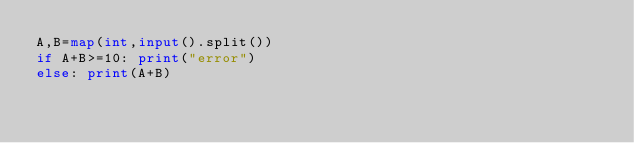Convert code to text. <code><loc_0><loc_0><loc_500><loc_500><_Python_>A,B=map(int,input().split())
if A+B>=10: print("error")
else: print(A+B)
</code> 